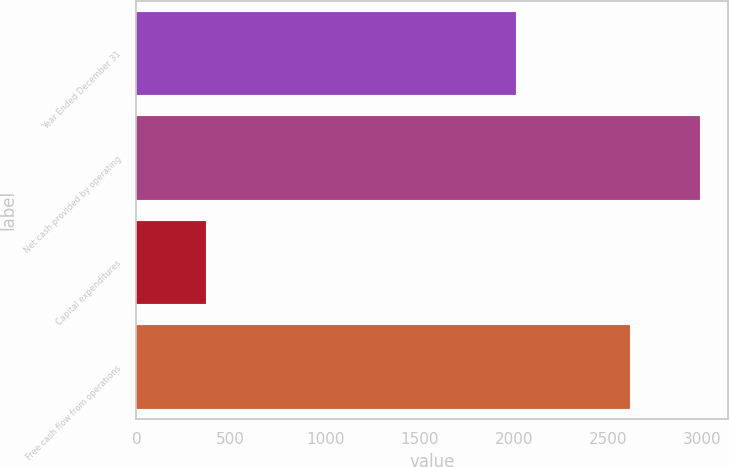<chart> <loc_0><loc_0><loc_500><loc_500><bar_chart><fcel>Year Ended December 31<fcel>Net cash provided by operating<fcel>Capital expenditures<fcel>Free cash flow from operations<nl><fcel>2010<fcel>2986<fcel>370<fcel>2616<nl></chart> 